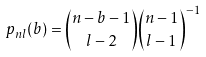Convert formula to latex. <formula><loc_0><loc_0><loc_500><loc_500>p _ { n l } ( b ) = { n - b - 1 \choose l - 2 } { n - 1 \choose l - 1 } ^ { - 1 }</formula> 